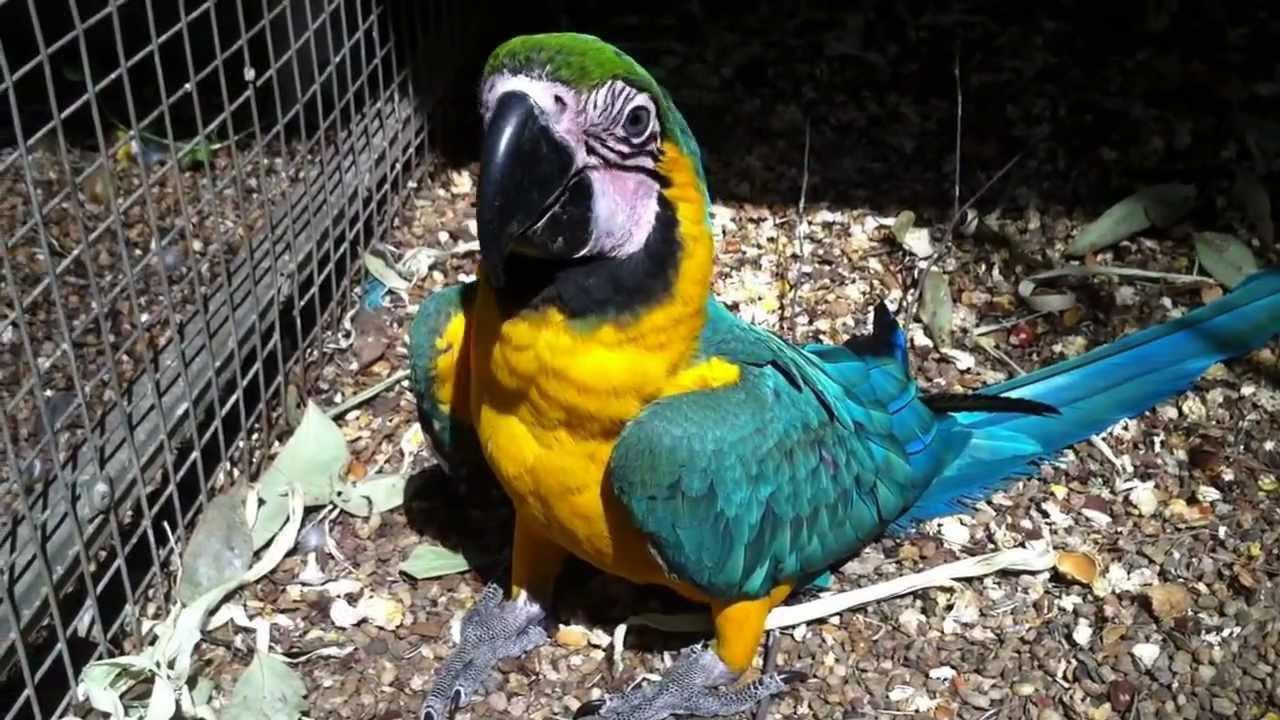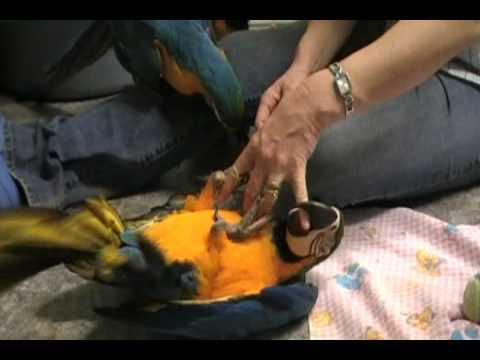The first image is the image on the left, the second image is the image on the right. Assess this claim about the two images: "The macaws are all on their feet.". Correct or not? Answer yes or no. No. The first image is the image on the left, the second image is the image on the right. Considering the images on both sides, is "There are plastic rings linked" valid? Answer yes or no. No. 